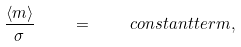<formula> <loc_0><loc_0><loc_500><loc_500>\frac { \langle m \rangle } { \sigma } \quad = \quad c o n s t a n t t e r m ,</formula> 